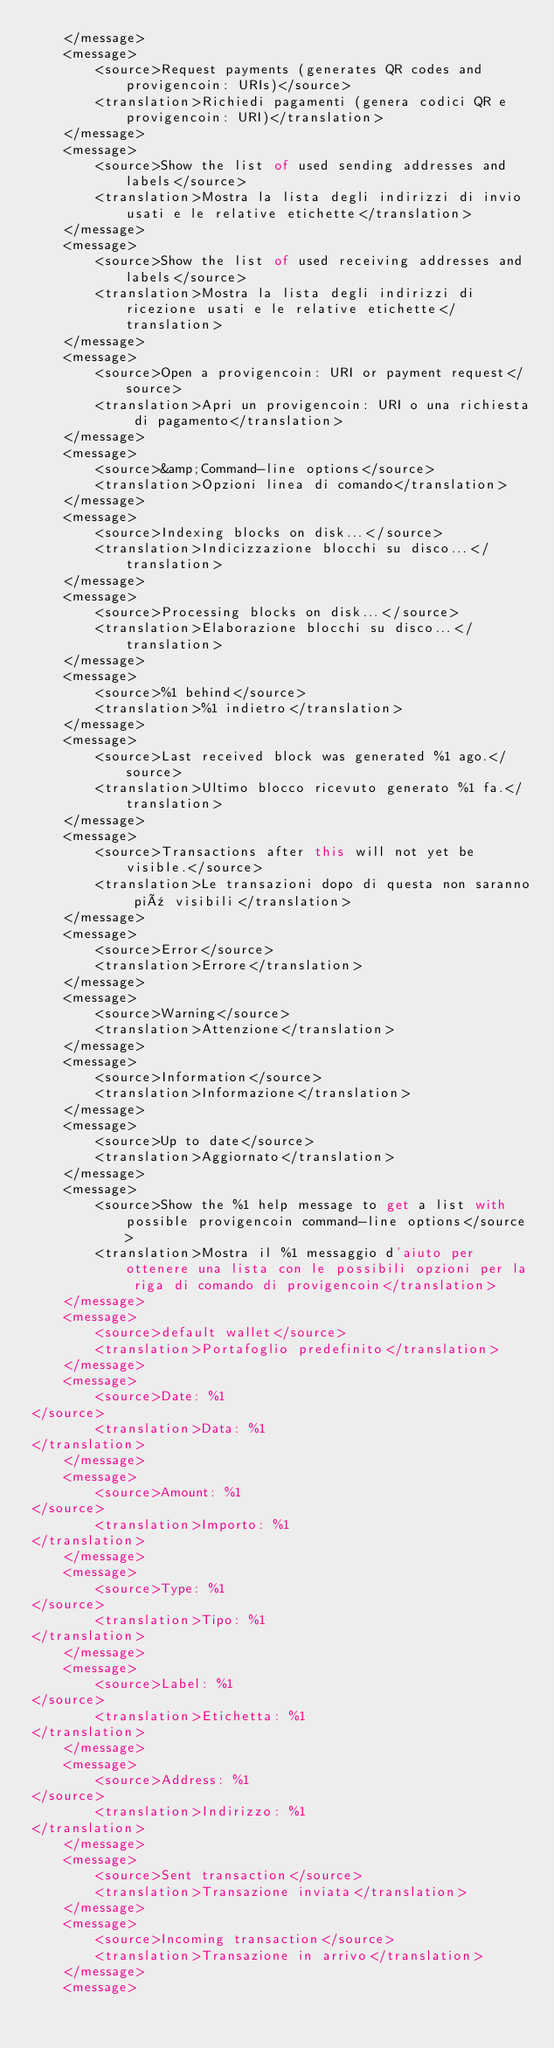Convert code to text. <code><loc_0><loc_0><loc_500><loc_500><_TypeScript_>    </message>
    <message>
        <source>Request payments (generates QR codes and provigencoin: URIs)</source>
        <translation>Richiedi pagamenti (genera codici QR e provigencoin: URI)</translation>
    </message>
    <message>
        <source>Show the list of used sending addresses and labels</source>
        <translation>Mostra la lista degli indirizzi di invio usati e le relative etichette</translation>
    </message>
    <message>
        <source>Show the list of used receiving addresses and labels</source>
        <translation>Mostra la lista degli indirizzi di ricezione usati e le relative etichette</translation>
    </message>
    <message>
        <source>Open a provigencoin: URI or payment request</source>
        <translation>Apri un provigencoin: URI o una richiesta di pagamento</translation>
    </message>
    <message>
        <source>&amp;Command-line options</source>
        <translation>Opzioni linea di comando</translation>
    </message>
    <message>
        <source>Indexing blocks on disk...</source>
        <translation>Indicizzazione blocchi su disco...</translation>
    </message>
    <message>
        <source>Processing blocks on disk...</source>
        <translation>Elaborazione blocchi su disco...</translation>
    </message>
    <message>
        <source>%1 behind</source>
        <translation>%1 indietro</translation>
    </message>
    <message>
        <source>Last received block was generated %1 ago.</source>
        <translation>Ultimo blocco ricevuto generato %1 fa.</translation>
    </message>
    <message>
        <source>Transactions after this will not yet be visible.</source>
        <translation>Le transazioni dopo di questa non saranno più visibili</translation>
    </message>
    <message>
        <source>Error</source>
        <translation>Errore</translation>
    </message>
    <message>
        <source>Warning</source>
        <translation>Attenzione</translation>
    </message>
    <message>
        <source>Information</source>
        <translation>Informazione</translation>
    </message>
    <message>
        <source>Up to date</source>
        <translation>Aggiornato</translation>
    </message>
    <message>
        <source>Show the %1 help message to get a list with possible provigencoin command-line options</source>
        <translation>Mostra il %1 messaggio d'aiuto per ottenere una lista con le possibili opzioni per la riga di comando di provigencoin</translation>
    </message>
    <message>
        <source>default wallet</source>
        <translation>Portafoglio predefinito</translation>
    </message>
    <message>
        <source>Date: %1
</source>
        <translation>Data: %1
</translation>
    </message>
    <message>
        <source>Amount: %1
</source>
        <translation>Importo: %1
</translation>
    </message>
    <message>
        <source>Type: %1
</source>
        <translation>Tipo: %1
</translation>
    </message>
    <message>
        <source>Label: %1
</source>
        <translation>Etichetta: %1
</translation>
    </message>
    <message>
        <source>Address: %1
</source>
        <translation>Indirizzo: %1
</translation>
    </message>
    <message>
        <source>Sent transaction</source>
        <translation>Transazione inviata</translation>
    </message>
    <message>
        <source>Incoming transaction</source>
        <translation>Transazione in arrivo</translation>
    </message>
    <message></code> 